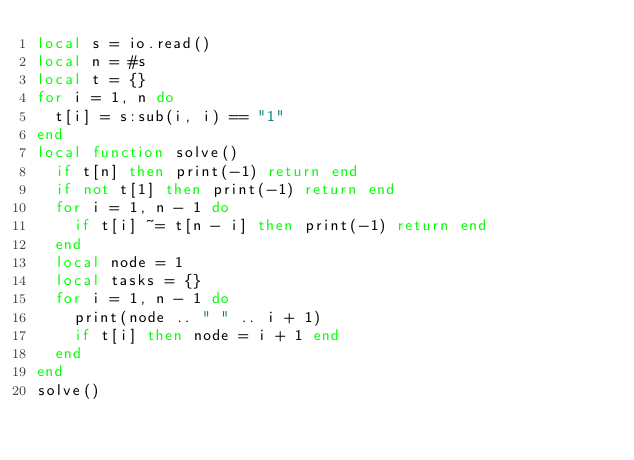<code> <loc_0><loc_0><loc_500><loc_500><_Lua_>local s = io.read()
local n = #s
local t = {}
for i = 1, n do
  t[i] = s:sub(i, i) == "1"
end
local function solve()
  if t[n] then print(-1) return end
  if not t[1] then print(-1) return end
  for i = 1, n - 1 do
    if t[i] ~= t[n - i] then print(-1) return end
  end
  local node = 1
  local tasks = {}
  for i = 1, n - 1 do
    print(node .. " " .. i + 1)
    if t[i] then node = i + 1 end
  end
end
solve()
</code> 